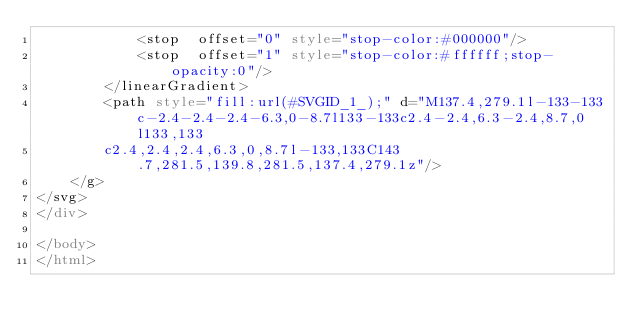Convert code to text. <code><loc_0><loc_0><loc_500><loc_500><_HTML_>            <stop  offset="0" style="stop-color:#000000"/>
            <stop  offset="1" style="stop-color:#ffffff;stop-opacity:0"/>
        </linearGradient>
        <path style="fill:url(#SVGID_1_);" d="M137.4,279.1l-133-133c-2.4-2.4-2.4-6.3,0-8.7l133-133c2.4-2.4,6.3-2.4,8.7,0l133,133
		c2.4,2.4,2.4,6.3,0,8.7l-133,133C143.7,281.5,139.8,281.5,137.4,279.1z"/>
    </g>
</svg>
</div>

</body>
</html></code> 